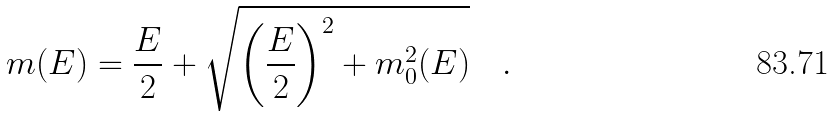<formula> <loc_0><loc_0><loc_500><loc_500>m ( E ) = \frac { E } { 2 } + \sqrt { \left ( \frac { E } { 2 } \right ) ^ { 2 } + m _ { 0 } ^ { 2 } ( E ) } \quad .</formula> 